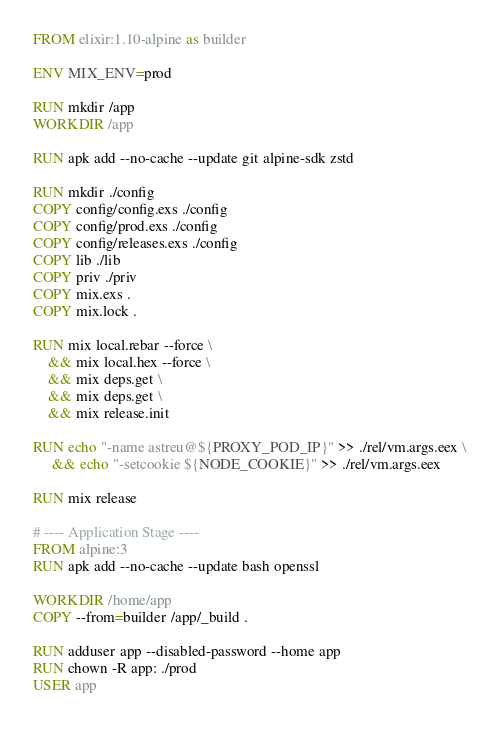Convert code to text. <code><loc_0><loc_0><loc_500><loc_500><_Dockerfile_>FROM elixir:1.10-alpine as builder

ENV MIX_ENV=prod

RUN mkdir /app
WORKDIR /app

RUN apk add --no-cache --update git alpine-sdk zstd

RUN mkdir ./config
COPY config/config.exs ./config
COPY config/prod.exs ./config
COPY config/releases.exs ./config
COPY lib ./lib
COPY priv ./priv
COPY mix.exs .
COPY mix.lock .

RUN mix local.rebar --force \
    && mix local.hex --force \
    && mix deps.get \
    && mix deps.get \
    && mix release.init

RUN echo "-name astreu@${PROXY_POD_IP}" >> ./rel/vm.args.eex \
     && echo "-setcookie ${NODE_COOKIE}" >> ./rel/vm.args.eex
    
RUN mix release

# ---- Application Stage ----
FROM alpine:3
RUN apk add --no-cache --update bash openssl

WORKDIR /home/app
COPY --from=builder /app/_build .

RUN adduser app --disabled-password --home app
RUN chown -R app: ./prod
USER app
</code> 